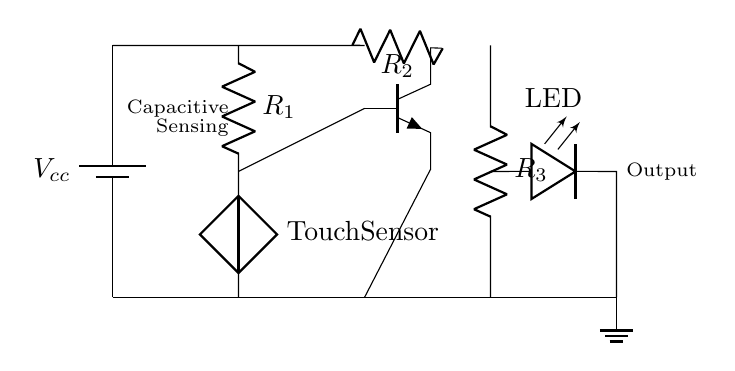What is the type of sensor used in this circuit? The circuit uses a capacitive touch sensor as indicated by the label "Touch Sensor" connected to a resistor.
Answer: capacitive touch sensor What does the transistor in this circuit do? The transistor acts as a switch that controls the flow of current to the output (LED) based on the input from the touch sensor.
Answer: switch What is the purpose of resistor R2? Resistor R2 is used to limit the current flowing through the transistor and provides necessary biasing for the transistor’s base.
Answer: current limiting How many resistors are present in this circuit? There are three resistors labeled R1, R2, and R3 shown in the diagram.
Answer: three What is the output component in the circuit? The output component is an LED, which lights up when the circuit is activated by the touch sensor.
Answer: LED What would happen if R1 is removed from the circuit? Removing R1 would disrupt the voltage supplied to the touch sensor, possibly preventing the sensor from functioning correctly in detecting touches.
Answer: sensor malfunction What type of circuit is this? This circuit is an interactive exhibit circuit designed to respond to touch inputs with visual output (LED lighting).
Answer: interactive exhibit circuit 